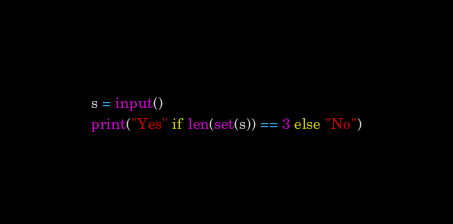Convert code to text. <code><loc_0><loc_0><loc_500><loc_500><_Python_>s = input()
print("Yes" if len(set(s)) == 3 else "No")
</code> 